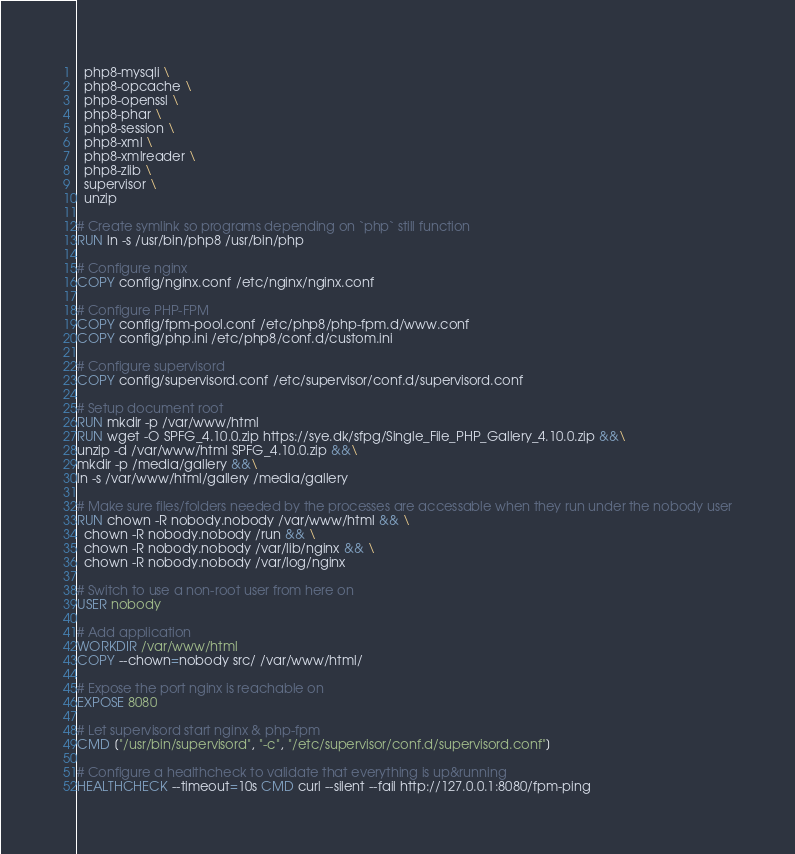Convert code to text. <code><loc_0><loc_0><loc_500><loc_500><_Dockerfile_>  php8-mysqli \
  php8-opcache \
  php8-openssl \
  php8-phar \
  php8-session \
  php8-xml \
  php8-xmlreader \
  php8-zlib \
  supervisor \
  unzip

# Create symlink so programs depending on `php` still function
RUN ln -s /usr/bin/php8 /usr/bin/php

# Configure nginx
COPY config/nginx.conf /etc/nginx/nginx.conf

# Configure PHP-FPM
COPY config/fpm-pool.conf /etc/php8/php-fpm.d/www.conf
COPY config/php.ini /etc/php8/conf.d/custom.ini

# Configure supervisord
COPY config/supervisord.conf /etc/supervisor/conf.d/supervisord.conf

# Setup document root
RUN mkdir -p /var/www/html
RUN wget -O SPFG_4.10.0.zip https://sye.dk/sfpg/Single_File_PHP_Gallery_4.10.0.zip &&\
unzip -d /var/www/html SPFG_4.10.0.zip &&\
mkdir -p /media/gallery &&\
ln -s /var/www/html/gallery /media/gallery

# Make sure files/folders needed by the processes are accessable when they run under the nobody user
RUN chown -R nobody.nobody /var/www/html && \
  chown -R nobody.nobody /run && \
  chown -R nobody.nobody /var/lib/nginx && \
  chown -R nobody.nobody /var/log/nginx

# Switch to use a non-root user from here on
USER nobody

# Add application
WORKDIR /var/www/html
COPY --chown=nobody src/ /var/www/html/

# Expose the port nginx is reachable on
EXPOSE 8080

# Let supervisord start nginx & php-fpm
CMD ["/usr/bin/supervisord", "-c", "/etc/supervisor/conf.d/supervisord.conf"]

# Configure a healthcheck to validate that everything is up&running
HEALTHCHECK --timeout=10s CMD curl --silent --fail http://127.0.0.1:8080/fpm-ping
</code> 